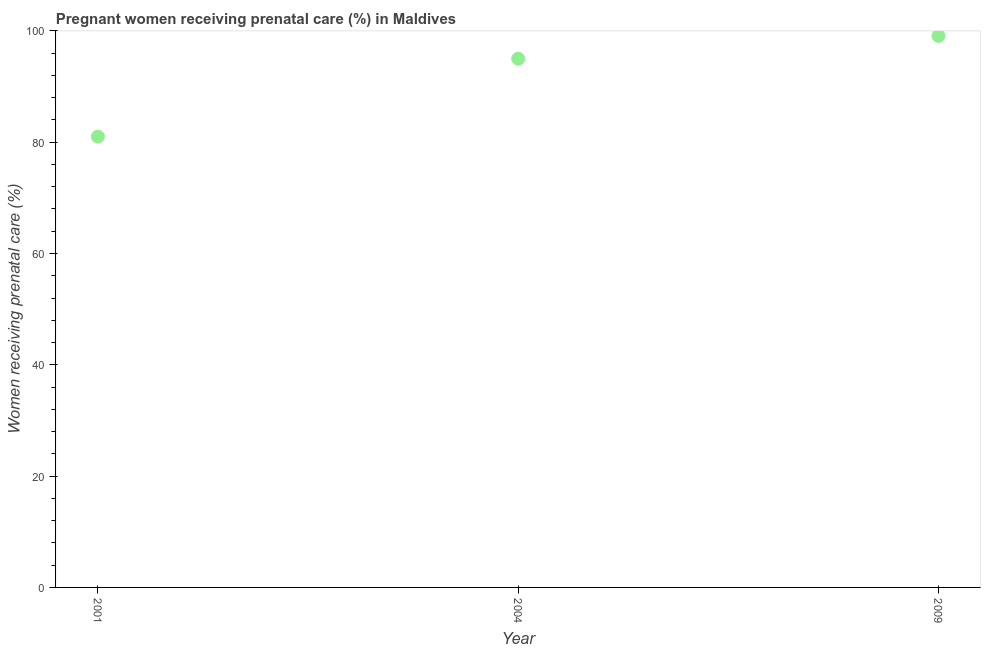What is the percentage of pregnant women receiving prenatal care in 2001?
Provide a succinct answer. 81. Across all years, what is the maximum percentage of pregnant women receiving prenatal care?
Your answer should be compact. 99.1. In which year was the percentage of pregnant women receiving prenatal care minimum?
Ensure brevity in your answer.  2001. What is the sum of the percentage of pregnant women receiving prenatal care?
Ensure brevity in your answer.  275.1. What is the difference between the percentage of pregnant women receiving prenatal care in 2001 and 2009?
Your answer should be very brief. -18.1. What is the average percentage of pregnant women receiving prenatal care per year?
Your answer should be compact. 91.7. What is the median percentage of pregnant women receiving prenatal care?
Keep it short and to the point. 95. Do a majority of the years between 2001 and 2004 (inclusive) have percentage of pregnant women receiving prenatal care greater than 32 %?
Provide a succinct answer. Yes. What is the ratio of the percentage of pregnant women receiving prenatal care in 2001 to that in 2004?
Ensure brevity in your answer.  0.85. What is the difference between the highest and the second highest percentage of pregnant women receiving prenatal care?
Keep it short and to the point. 4.1. Is the sum of the percentage of pregnant women receiving prenatal care in 2001 and 2009 greater than the maximum percentage of pregnant women receiving prenatal care across all years?
Your response must be concise. Yes. What is the difference between the highest and the lowest percentage of pregnant women receiving prenatal care?
Ensure brevity in your answer.  18.1. In how many years, is the percentage of pregnant women receiving prenatal care greater than the average percentage of pregnant women receiving prenatal care taken over all years?
Your answer should be very brief. 2. How many dotlines are there?
Provide a succinct answer. 1. Are the values on the major ticks of Y-axis written in scientific E-notation?
Make the answer very short. No. Does the graph contain any zero values?
Your answer should be compact. No. Does the graph contain grids?
Keep it short and to the point. No. What is the title of the graph?
Provide a short and direct response. Pregnant women receiving prenatal care (%) in Maldives. What is the label or title of the Y-axis?
Provide a succinct answer. Women receiving prenatal care (%). What is the Women receiving prenatal care (%) in 2009?
Provide a succinct answer. 99.1. What is the difference between the Women receiving prenatal care (%) in 2001 and 2004?
Provide a succinct answer. -14. What is the difference between the Women receiving prenatal care (%) in 2001 and 2009?
Your answer should be compact. -18.1. What is the ratio of the Women receiving prenatal care (%) in 2001 to that in 2004?
Your answer should be very brief. 0.85. What is the ratio of the Women receiving prenatal care (%) in 2001 to that in 2009?
Make the answer very short. 0.82. 